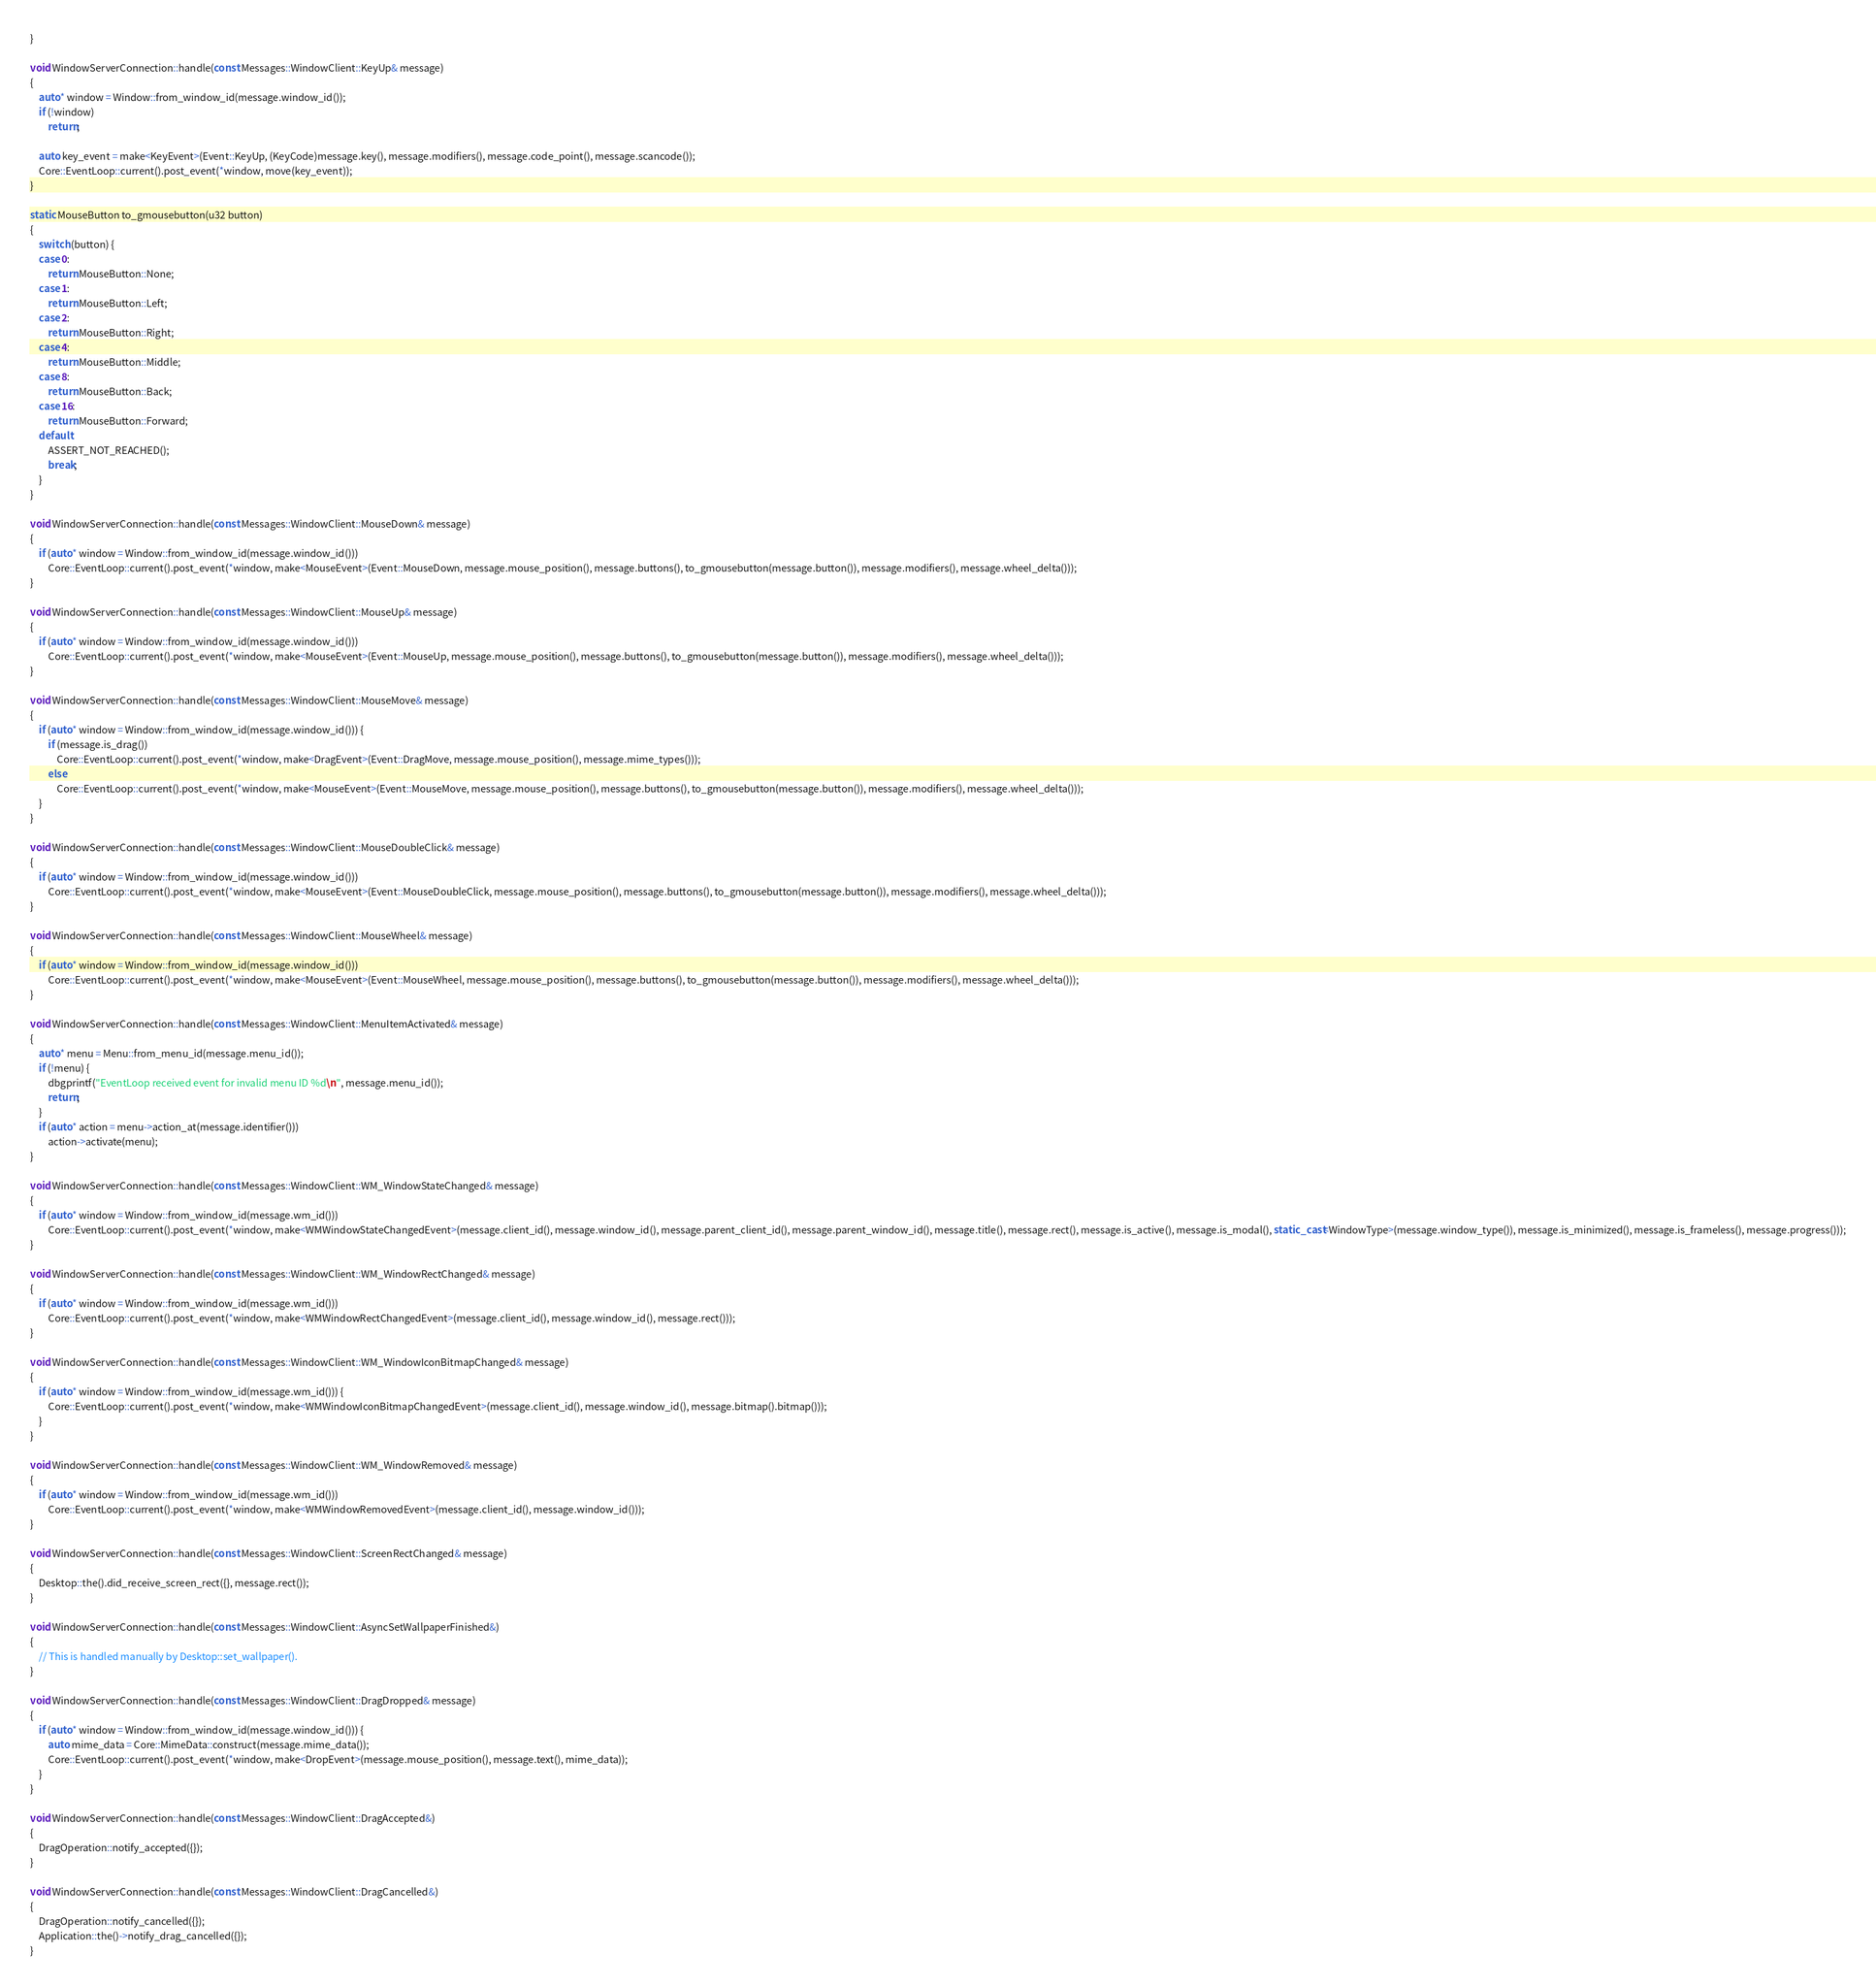Convert code to text. <code><loc_0><loc_0><loc_500><loc_500><_C++_>}

void WindowServerConnection::handle(const Messages::WindowClient::KeyUp& message)
{
    auto* window = Window::from_window_id(message.window_id());
    if (!window)
        return;

    auto key_event = make<KeyEvent>(Event::KeyUp, (KeyCode)message.key(), message.modifiers(), message.code_point(), message.scancode());
    Core::EventLoop::current().post_event(*window, move(key_event));
}

static MouseButton to_gmousebutton(u32 button)
{
    switch (button) {
    case 0:
        return MouseButton::None;
    case 1:
        return MouseButton::Left;
    case 2:
        return MouseButton::Right;
    case 4:
        return MouseButton::Middle;
    case 8:
        return MouseButton::Back;
    case 16:
        return MouseButton::Forward;
    default:
        ASSERT_NOT_REACHED();
        break;
    }
}

void WindowServerConnection::handle(const Messages::WindowClient::MouseDown& message)
{
    if (auto* window = Window::from_window_id(message.window_id()))
        Core::EventLoop::current().post_event(*window, make<MouseEvent>(Event::MouseDown, message.mouse_position(), message.buttons(), to_gmousebutton(message.button()), message.modifiers(), message.wheel_delta()));
}

void WindowServerConnection::handle(const Messages::WindowClient::MouseUp& message)
{
    if (auto* window = Window::from_window_id(message.window_id()))
        Core::EventLoop::current().post_event(*window, make<MouseEvent>(Event::MouseUp, message.mouse_position(), message.buttons(), to_gmousebutton(message.button()), message.modifiers(), message.wheel_delta()));
}

void WindowServerConnection::handle(const Messages::WindowClient::MouseMove& message)
{
    if (auto* window = Window::from_window_id(message.window_id())) {
        if (message.is_drag())
            Core::EventLoop::current().post_event(*window, make<DragEvent>(Event::DragMove, message.mouse_position(), message.mime_types()));
        else
            Core::EventLoop::current().post_event(*window, make<MouseEvent>(Event::MouseMove, message.mouse_position(), message.buttons(), to_gmousebutton(message.button()), message.modifiers(), message.wheel_delta()));
    }
}

void WindowServerConnection::handle(const Messages::WindowClient::MouseDoubleClick& message)
{
    if (auto* window = Window::from_window_id(message.window_id()))
        Core::EventLoop::current().post_event(*window, make<MouseEvent>(Event::MouseDoubleClick, message.mouse_position(), message.buttons(), to_gmousebutton(message.button()), message.modifiers(), message.wheel_delta()));
}

void WindowServerConnection::handle(const Messages::WindowClient::MouseWheel& message)
{
    if (auto* window = Window::from_window_id(message.window_id()))
        Core::EventLoop::current().post_event(*window, make<MouseEvent>(Event::MouseWheel, message.mouse_position(), message.buttons(), to_gmousebutton(message.button()), message.modifiers(), message.wheel_delta()));
}

void WindowServerConnection::handle(const Messages::WindowClient::MenuItemActivated& message)
{
    auto* menu = Menu::from_menu_id(message.menu_id());
    if (!menu) {
        dbgprintf("EventLoop received event for invalid menu ID %d\n", message.menu_id());
        return;
    }
    if (auto* action = menu->action_at(message.identifier()))
        action->activate(menu);
}

void WindowServerConnection::handle(const Messages::WindowClient::WM_WindowStateChanged& message)
{
    if (auto* window = Window::from_window_id(message.wm_id()))
        Core::EventLoop::current().post_event(*window, make<WMWindowStateChangedEvent>(message.client_id(), message.window_id(), message.parent_client_id(), message.parent_window_id(), message.title(), message.rect(), message.is_active(), message.is_modal(), static_cast<WindowType>(message.window_type()), message.is_minimized(), message.is_frameless(), message.progress()));
}

void WindowServerConnection::handle(const Messages::WindowClient::WM_WindowRectChanged& message)
{
    if (auto* window = Window::from_window_id(message.wm_id()))
        Core::EventLoop::current().post_event(*window, make<WMWindowRectChangedEvent>(message.client_id(), message.window_id(), message.rect()));
}

void WindowServerConnection::handle(const Messages::WindowClient::WM_WindowIconBitmapChanged& message)
{
    if (auto* window = Window::from_window_id(message.wm_id())) {
        Core::EventLoop::current().post_event(*window, make<WMWindowIconBitmapChangedEvent>(message.client_id(), message.window_id(), message.bitmap().bitmap()));
    }
}

void WindowServerConnection::handle(const Messages::WindowClient::WM_WindowRemoved& message)
{
    if (auto* window = Window::from_window_id(message.wm_id()))
        Core::EventLoop::current().post_event(*window, make<WMWindowRemovedEvent>(message.client_id(), message.window_id()));
}

void WindowServerConnection::handle(const Messages::WindowClient::ScreenRectChanged& message)
{
    Desktop::the().did_receive_screen_rect({}, message.rect());
}

void WindowServerConnection::handle(const Messages::WindowClient::AsyncSetWallpaperFinished&)
{
    // This is handled manually by Desktop::set_wallpaper().
}

void WindowServerConnection::handle(const Messages::WindowClient::DragDropped& message)
{
    if (auto* window = Window::from_window_id(message.window_id())) {
        auto mime_data = Core::MimeData::construct(message.mime_data());
        Core::EventLoop::current().post_event(*window, make<DropEvent>(message.mouse_position(), message.text(), mime_data));
    }
}

void WindowServerConnection::handle(const Messages::WindowClient::DragAccepted&)
{
    DragOperation::notify_accepted({});
}

void WindowServerConnection::handle(const Messages::WindowClient::DragCancelled&)
{
    DragOperation::notify_cancelled({});
    Application::the()->notify_drag_cancelled({});
}
</code> 